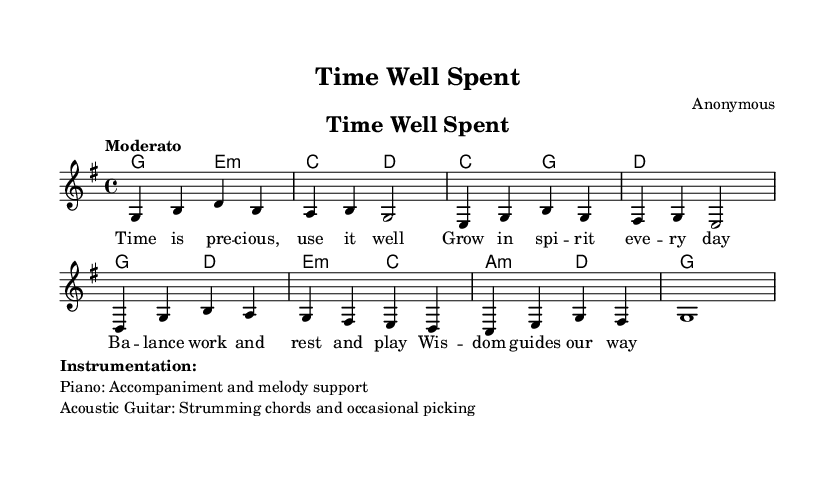What is the key signature of this music? The key signature is indicated at the beginning of the staff and shows one sharp, which represents G major.
Answer: G major What is the time signature of this music? The time signature is found at the start of the score and shows a 4 on top of a 4, indicating four beats per measure.
Answer: 4/4 What is the tempo marking for this piece? The tempo marking, described as "Moderato", indicates a moderate speed of the music, found at the start of the score.
Answer: Moderato How many measures does the melody contain? By counting the individual measures notated in the melody part, we see there are a total of eight measures.
Answer: 8 What is the title of the piece? The title is explicitly stated in the header section of the score, which reads "Time Well Spent".
Answer: Time Well Spent What does the lyric "Wisdom guides our way" suggest about the theme? This lyric hints at the importance of making wise decisions in life, particularly regarding the use of time, which aligns with the song's focus on spiritual growth.
Answer: Spiritual growth What instruments are specified for this piece? The instrumentation is detailed in the markup section, listing piano for accompaniment and melody support, and acoustic guitar for strumming chords.
Answer: Piano and Acoustic Guitar 